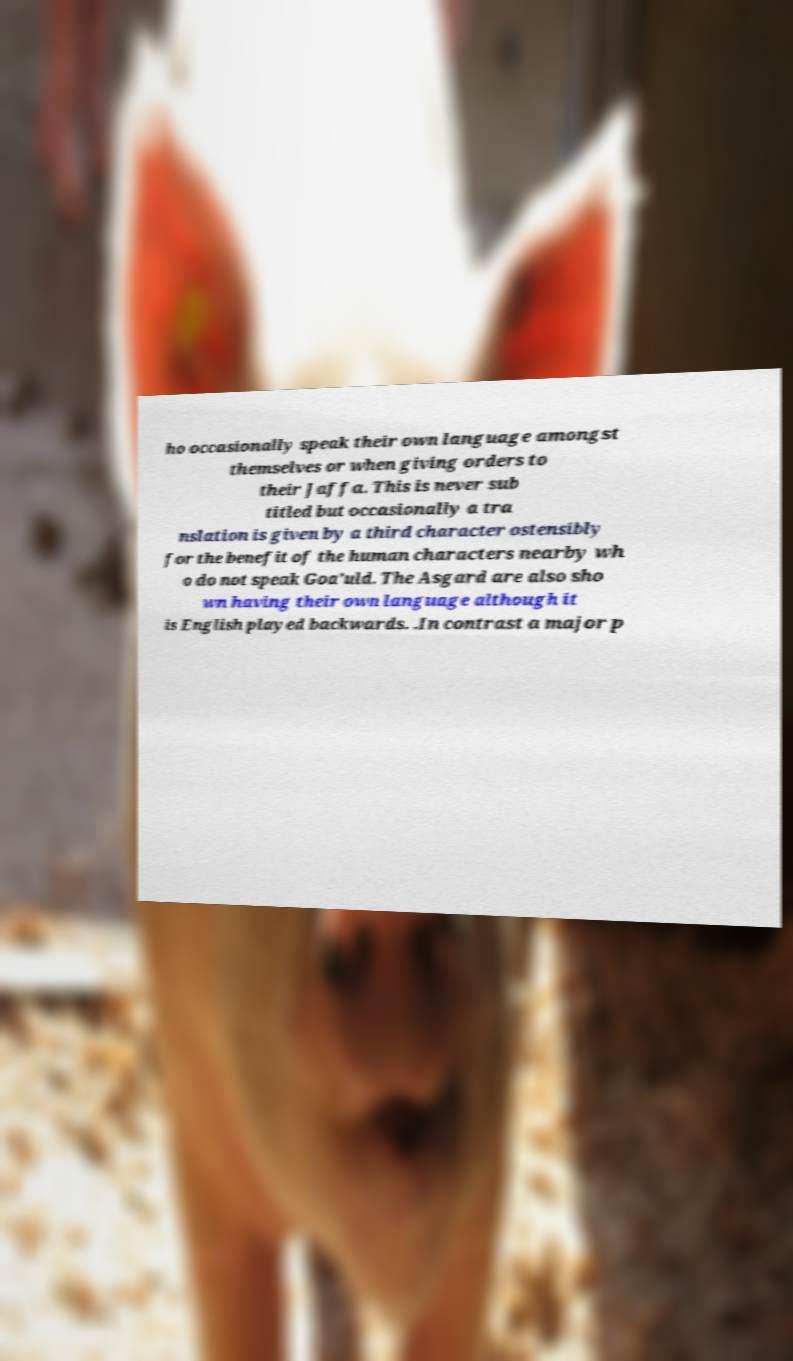Can you accurately transcribe the text from the provided image for me? ho occasionally speak their own language amongst themselves or when giving orders to their Jaffa. This is never sub titled but occasionally a tra nslation is given by a third character ostensibly for the benefit of the human characters nearby wh o do not speak Goa’uld. The Asgard are also sho wn having their own language although it is English played backwards. .In contrast a major p 